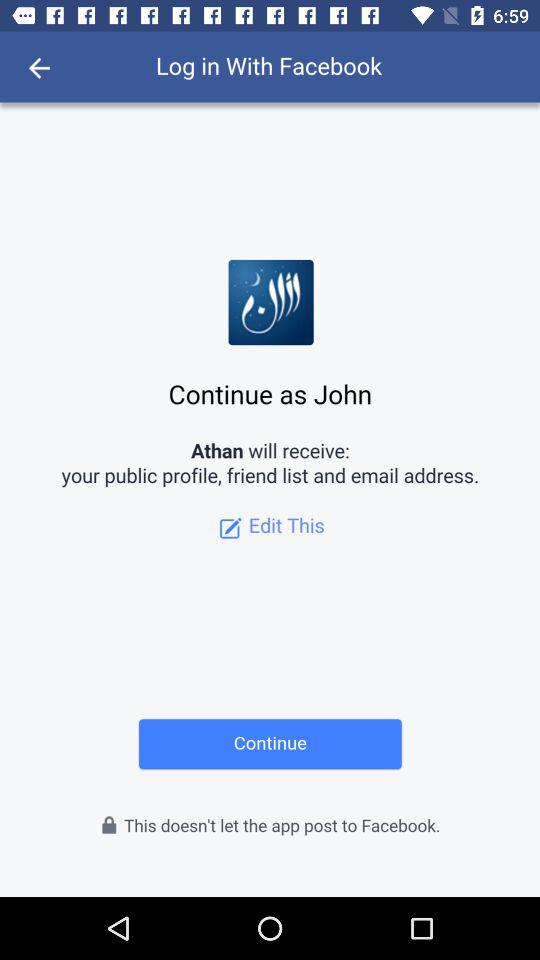What application is asking for permission? The application asking for permission is "Athan". 